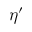Convert formula to latex. <formula><loc_0><loc_0><loc_500><loc_500>\eta ^ { \prime }</formula> 